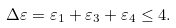<formula> <loc_0><loc_0><loc_500><loc_500>\Delta \varepsilon = \varepsilon _ { 1 } + \varepsilon _ { 3 } + \varepsilon _ { 4 } \leq 4 .</formula> 